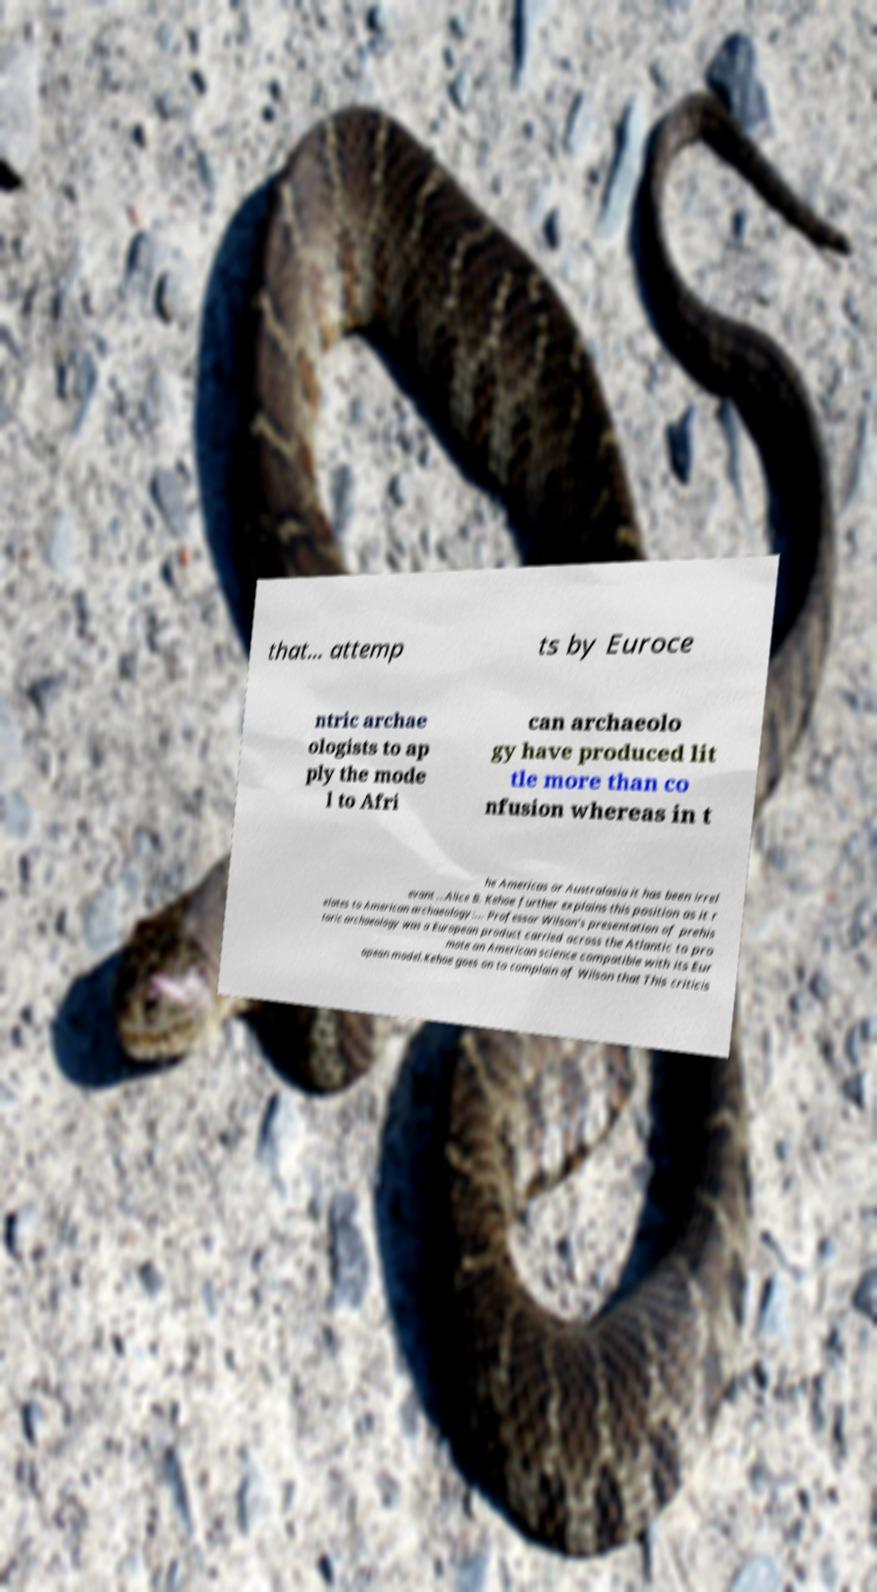I need the written content from this picture converted into text. Can you do that? that... attemp ts by Euroce ntric archae ologists to ap ply the mode l to Afri can archaeolo gy have produced lit tle more than co nfusion whereas in t he Americas or Australasia it has been irrel evant ...Alice B. Kehoe further explains this position as it r elates to American archaeology:... Professor Wilson's presentation of prehis toric archaeology was a European product carried across the Atlantic to pro mote an American science compatible with its Eur opean model.Kehoe goes on to complain of Wilson that This criticis 